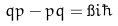Convert formula to latex. <formula><loc_0><loc_0><loc_500><loc_500>q p - p q = \i i \hbar</formula> 